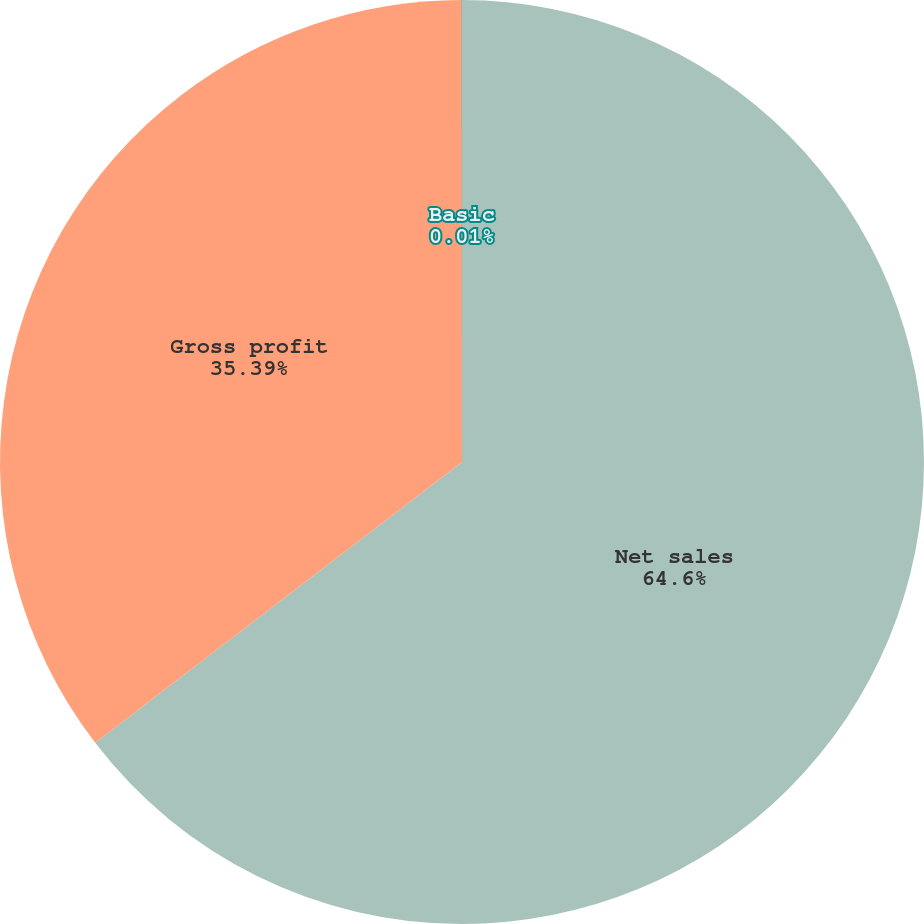Convert chart. <chart><loc_0><loc_0><loc_500><loc_500><pie_chart><fcel>Net sales<fcel>Gross profit<fcel>Basic<nl><fcel>64.6%<fcel>35.39%<fcel>0.01%<nl></chart> 